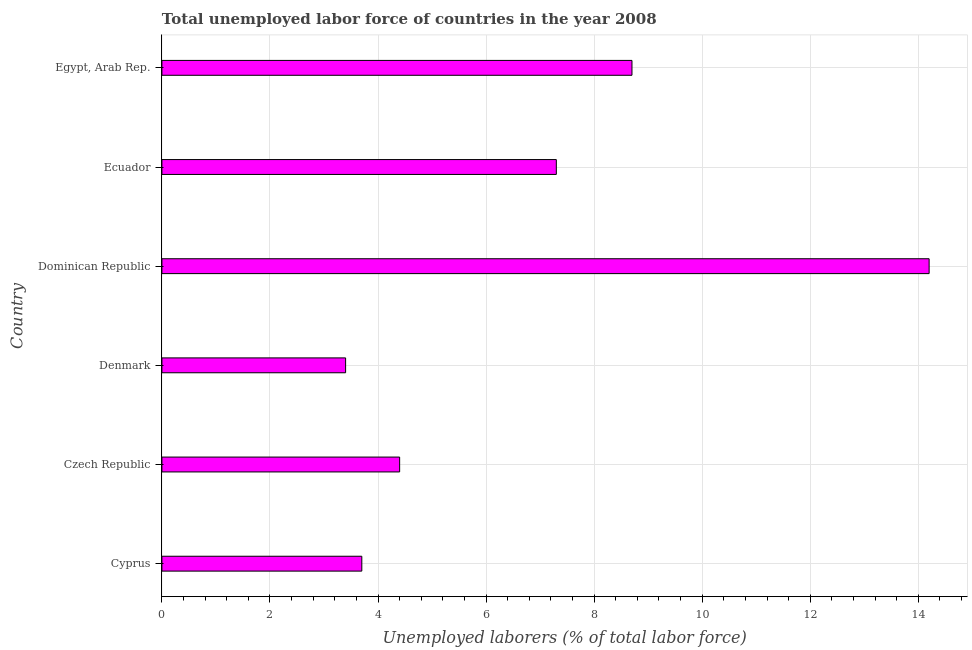Does the graph contain any zero values?
Provide a short and direct response. No. Does the graph contain grids?
Give a very brief answer. Yes. What is the title of the graph?
Make the answer very short. Total unemployed labor force of countries in the year 2008. What is the label or title of the X-axis?
Provide a short and direct response. Unemployed laborers (% of total labor force). What is the label or title of the Y-axis?
Offer a terse response. Country. What is the total unemployed labour force in Cyprus?
Offer a terse response. 3.7. Across all countries, what is the maximum total unemployed labour force?
Provide a succinct answer. 14.2. Across all countries, what is the minimum total unemployed labour force?
Ensure brevity in your answer.  3.4. In which country was the total unemployed labour force maximum?
Offer a terse response. Dominican Republic. What is the sum of the total unemployed labour force?
Provide a short and direct response. 41.7. What is the average total unemployed labour force per country?
Your response must be concise. 6.95. What is the median total unemployed labour force?
Ensure brevity in your answer.  5.85. In how many countries, is the total unemployed labour force greater than 12.8 %?
Your response must be concise. 1. What is the ratio of the total unemployed labour force in Czech Republic to that in Ecuador?
Give a very brief answer. 0.6. Is the difference between the total unemployed labour force in Dominican Republic and Ecuador greater than the difference between any two countries?
Offer a very short reply. No. What is the difference between the highest and the second highest total unemployed labour force?
Provide a short and direct response. 5.5. How many bars are there?
Your answer should be very brief. 6. Are all the bars in the graph horizontal?
Your answer should be very brief. Yes. Are the values on the major ticks of X-axis written in scientific E-notation?
Your response must be concise. No. What is the Unemployed laborers (% of total labor force) in Cyprus?
Your answer should be compact. 3.7. What is the Unemployed laborers (% of total labor force) in Czech Republic?
Your response must be concise. 4.4. What is the Unemployed laborers (% of total labor force) in Denmark?
Make the answer very short. 3.4. What is the Unemployed laborers (% of total labor force) of Dominican Republic?
Your response must be concise. 14.2. What is the Unemployed laborers (% of total labor force) of Ecuador?
Offer a very short reply. 7.3. What is the Unemployed laborers (% of total labor force) in Egypt, Arab Rep.?
Your answer should be very brief. 8.7. What is the difference between the Unemployed laborers (% of total labor force) in Cyprus and Czech Republic?
Your answer should be compact. -0.7. What is the difference between the Unemployed laborers (% of total labor force) in Cyprus and Ecuador?
Provide a short and direct response. -3.6. What is the difference between the Unemployed laborers (% of total labor force) in Cyprus and Egypt, Arab Rep.?
Your response must be concise. -5. What is the difference between the Unemployed laborers (% of total labor force) in Czech Republic and Denmark?
Provide a short and direct response. 1. What is the difference between the Unemployed laborers (% of total labor force) in Czech Republic and Dominican Republic?
Provide a succinct answer. -9.8. What is the difference between the Unemployed laborers (% of total labor force) in Denmark and Ecuador?
Your response must be concise. -3.9. What is the difference between the Unemployed laborers (% of total labor force) in Dominican Republic and Egypt, Arab Rep.?
Your response must be concise. 5.5. What is the ratio of the Unemployed laborers (% of total labor force) in Cyprus to that in Czech Republic?
Make the answer very short. 0.84. What is the ratio of the Unemployed laborers (% of total labor force) in Cyprus to that in Denmark?
Your answer should be compact. 1.09. What is the ratio of the Unemployed laborers (% of total labor force) in Cyprus to that in Dominican Republic?
Provide a short and direct response. 0.26. What is the ratio of the Unemployed laborers (% of total labor force) in Cyprus to that in Ecuador?
Provide a short and direct response. 0.51. What is the ratio of the Unemployed laborers (% of total labor force) in Cyprus to that in Egypt, Arab Rep.?
Make the answer very short. 0.42. What is the ratio of the Unemployed laborers (% of total labor force) in Czech Republic to that in Denmark?
Make the answer very short. 1.29. What is the ratio of the Unemployed laborers (% of total labor force) in Czech Republic to that in Dominican Republic?
Offer a very short reply. 0.31. What is the ratio of the Unemployed laborers (% of total labor force) in Czech Republic to that in Ecuador?
Give a very brief answer. 0.6. What is the ratio of the Unemployed laborers (% of total labor force) in Czech Republic to that in Egypt, Arab Rep.?
Offer a terse response. 0.51. What is the ratio of the Unemployed laborers (% of total labor force) in Denmark to that in Dominican Republic?
Ensure brevity in your answer.  0.24. What is the ratio of the Unemployed laborers (% of total labor force) in Denmark to that in Ecuador?
Offer a very short reply. 0.47. What is the ratio of the Unemployed laborers (% of total labor force) in Denmark to that in Egypt, Arab Rep.?
Provide a short and direct response. 0.39. What is the ratio of the Unemployed laborers (% of total labor force) in Dominican Republic to that in Ecuador?
Provide a succinct answer. 1.95. What is the ratio of the Unemployed laborers (% of total labor force) in Dominican Republic to that in Egypt, Arab Rep.?
Keep it short and to the point. 1.63. What is the ratio of the Unemployed laborers (% of total labor force) in Ecuador to that in Egypt, Arab Rep.?
Ensure brevity in your answer.  0.84. 